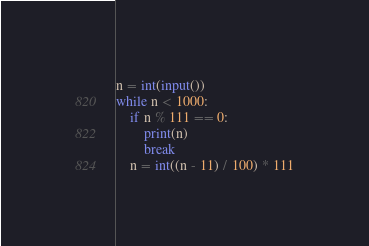Convert code to text. <code><loc_0><loc_0><loc_500><loc_500><_Python_>n = int(input())
while n < 1000:
    if n % 111 == 0:
        print(n)
        break
    n = int((n - 11) / 100) * 111
</code> 